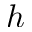Convert formula to latex. <formula><loc_0><loc_0><loc_500><loc_500>h</formula> 